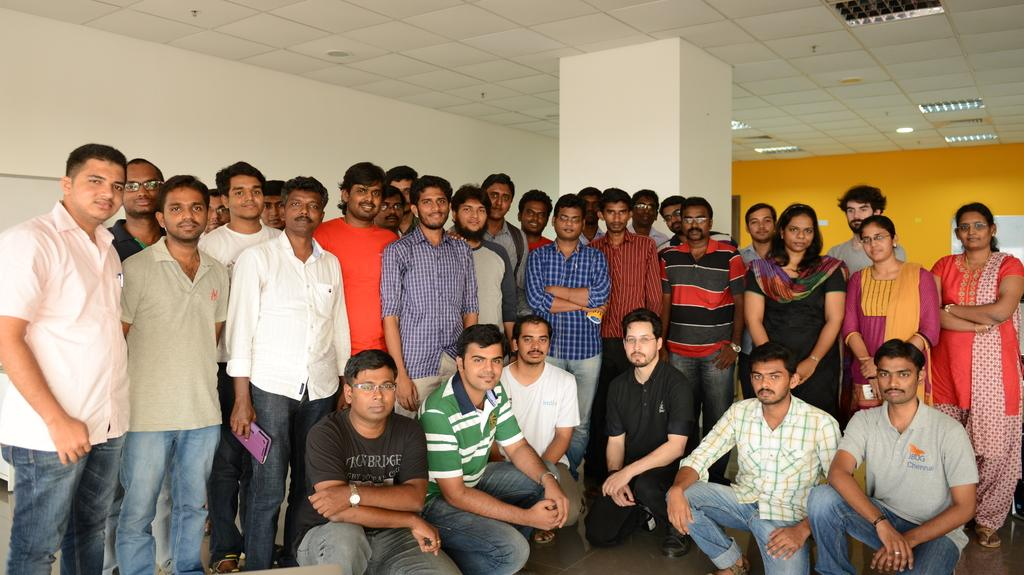How many people are in the image? There is a group of people in the image. Can you describe the arrangement of the people? The group of people is arranged from left to right. What is the person on the right holding? The person on the right is holding a violet color object in his hand. What structures can be seen in the background of the image? There is a pillar and a wall in the image. What is present above the people in the image? There are lights on top in the image. How many dolls are sitting on the wall in the image? There are no dolls present in the image; it features a group of people arranged from left to right, with a pillar and a wall in the background. Can you tell me how many dogs are visible in the image? There are no dogs visible in the image. 